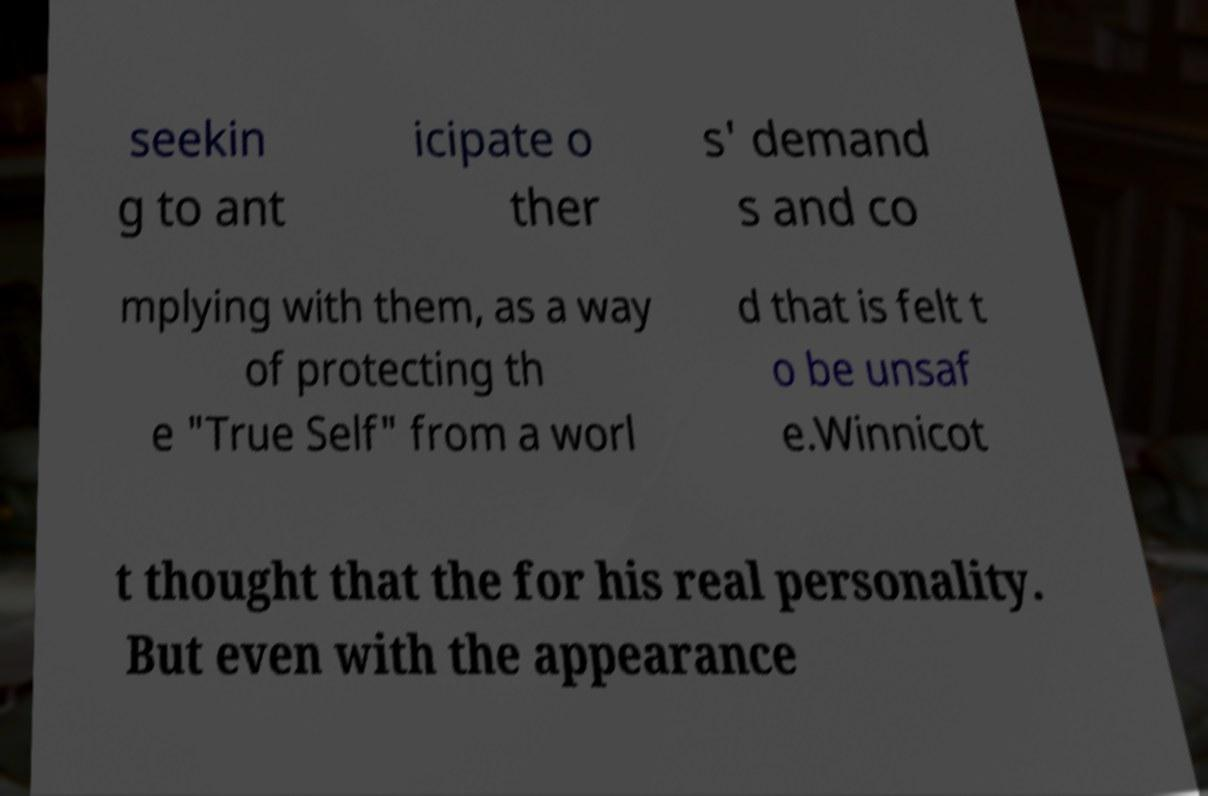Please identify and transcribe the text found in this image. seekin g to ant icipate o ther s' demand s and co mplying with them, as a way of protecting th e "True Self" from a worl d that is felt t o be unsaf e.Winnicot t thought that the for his real personality. But even with the appearance 